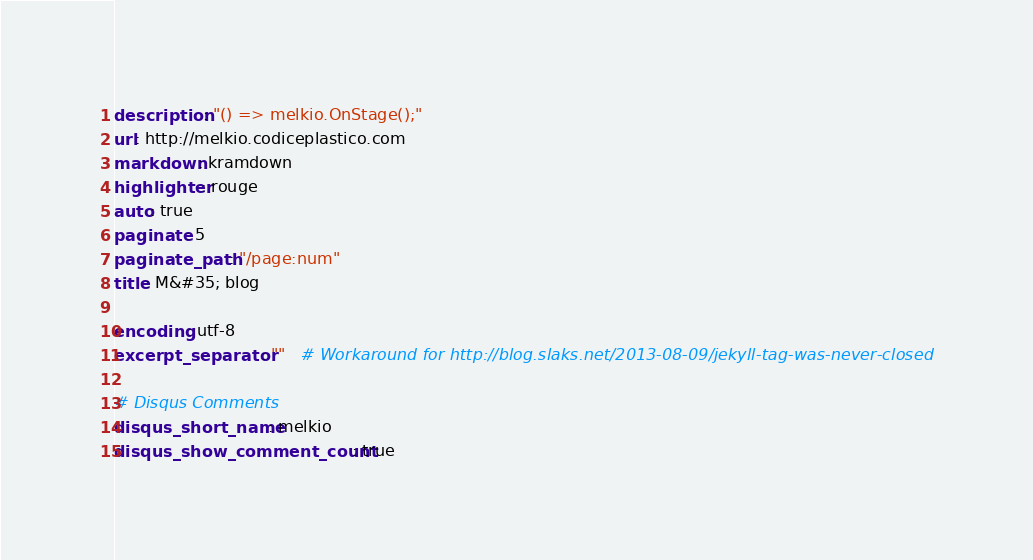Convert code to text. <code><loc_0><loc_0><loc_500><loc_500><_YAML_>description: "() => melkio.OnStage();"
url: http://melkio.codiceplastico.com
markdown: kramdown
highlighter: rouge
auto: true
paginate: 5
paginate_path: "/page:num"
title: M&#35; blog

encoding: utf-8
excerpt_separator: ""   # Workaround for http://blog.slaks.net/2013-08-09/jekyll-tag-was-never-closed

# Disqus Comments
disqus_short_name: melkio
disqus_show_comment_count: true
</code> 